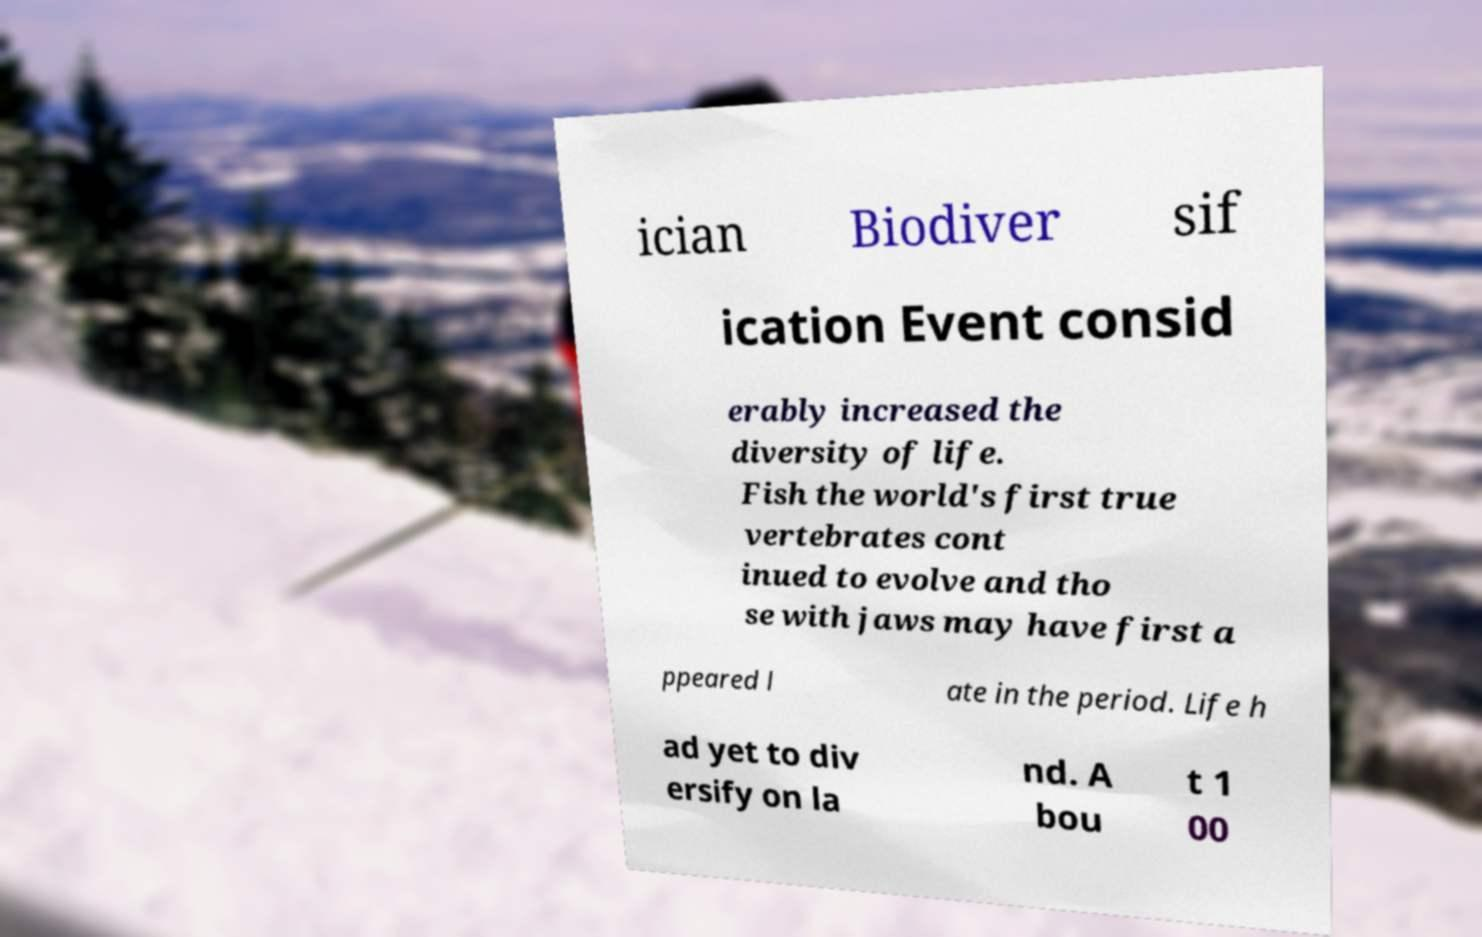Can you accurately transcribe the text from the provided image for me? ician Biodiver sif ication Event consid erably increased the diversity of life. Fish the world's first true vertebrates cont inued to evolve and tho se with jaws may have first a ppeared l ate in the period. Life h ad yet to div ersify on la nd. A bou t 1 00 